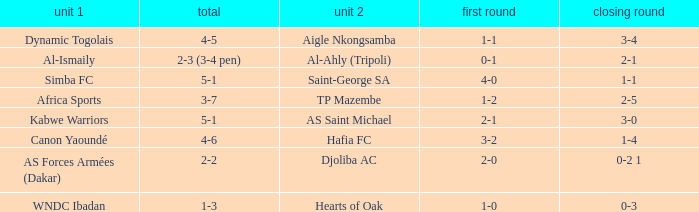What team played against Hafia FC (team 2)? Canon Yaoundé. 